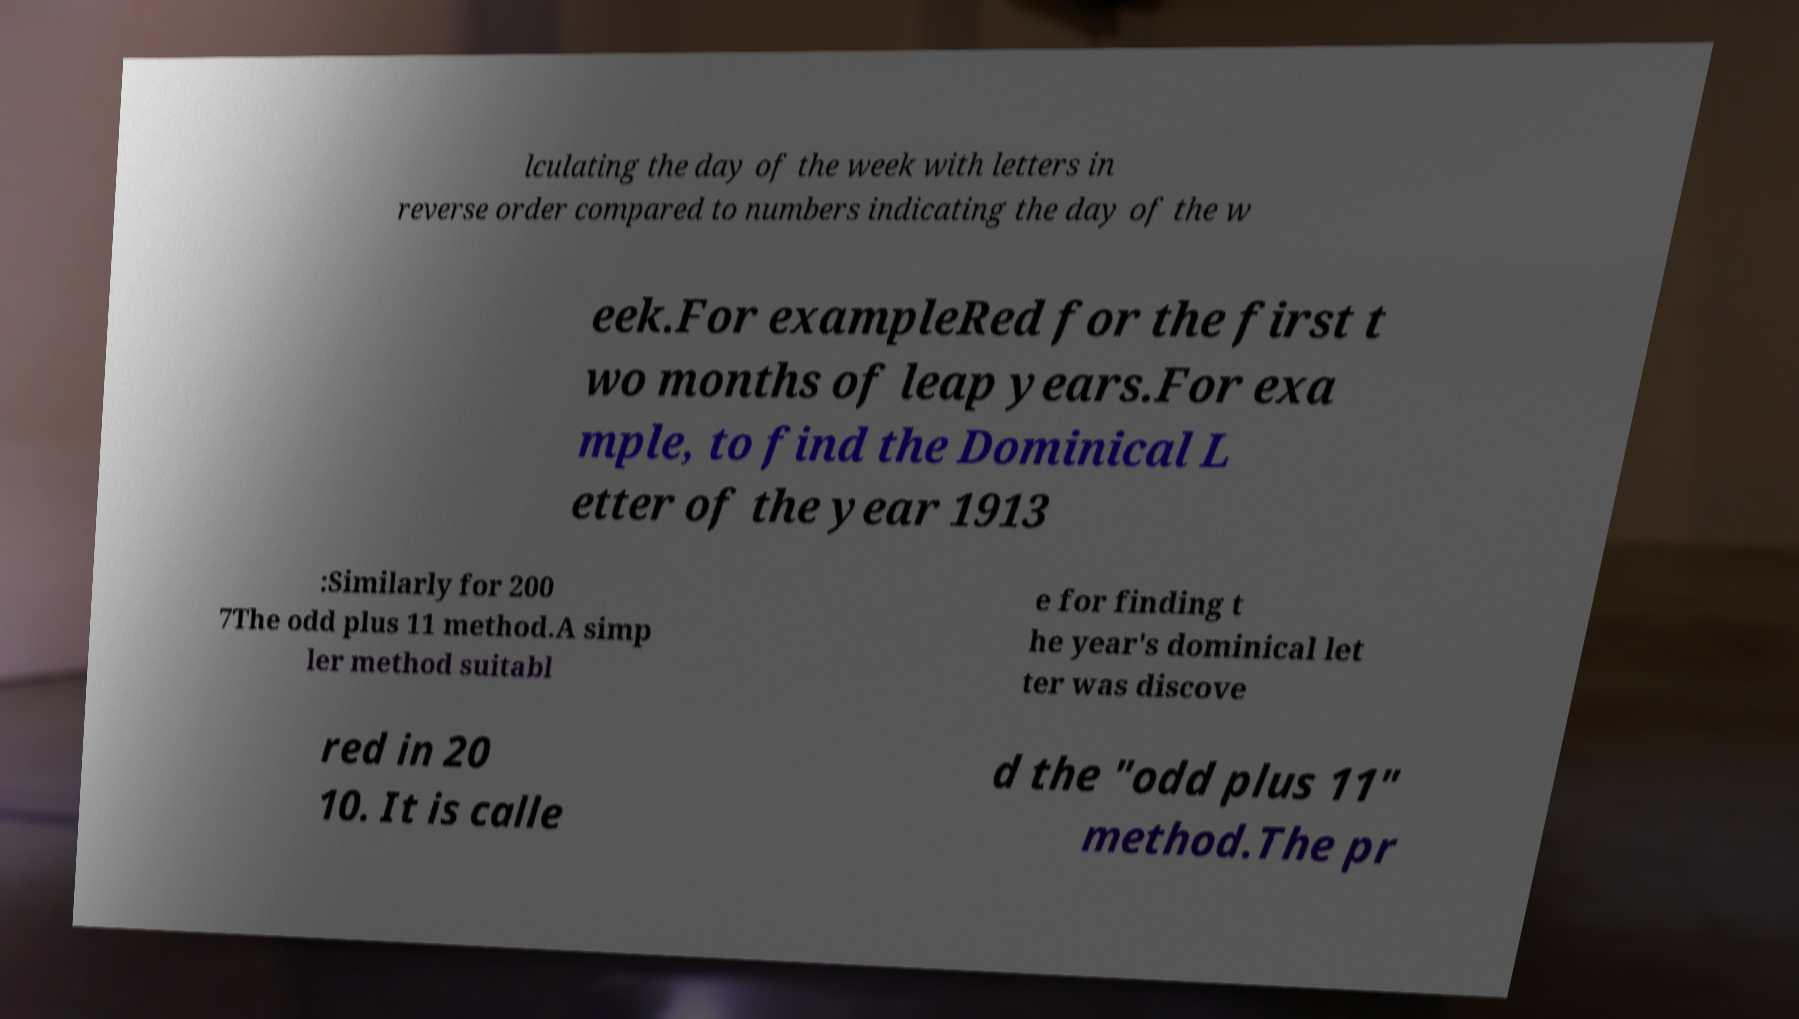Please identify and transcribe the text found in this image. lculating the day of the week with letters in reverse order compared to numbers indicating the day of the w eek.For exampleRed for the first t wo months of leap years.For exa mple, to find the Dominical L etter of the year 1913 :Similarly for 200 7The odd plus 11 method.A simp ler method suitabl e for finding t he year's dominical let ter was discove red in 20 10. It is calle d the "odd plus 11" method.The pr 